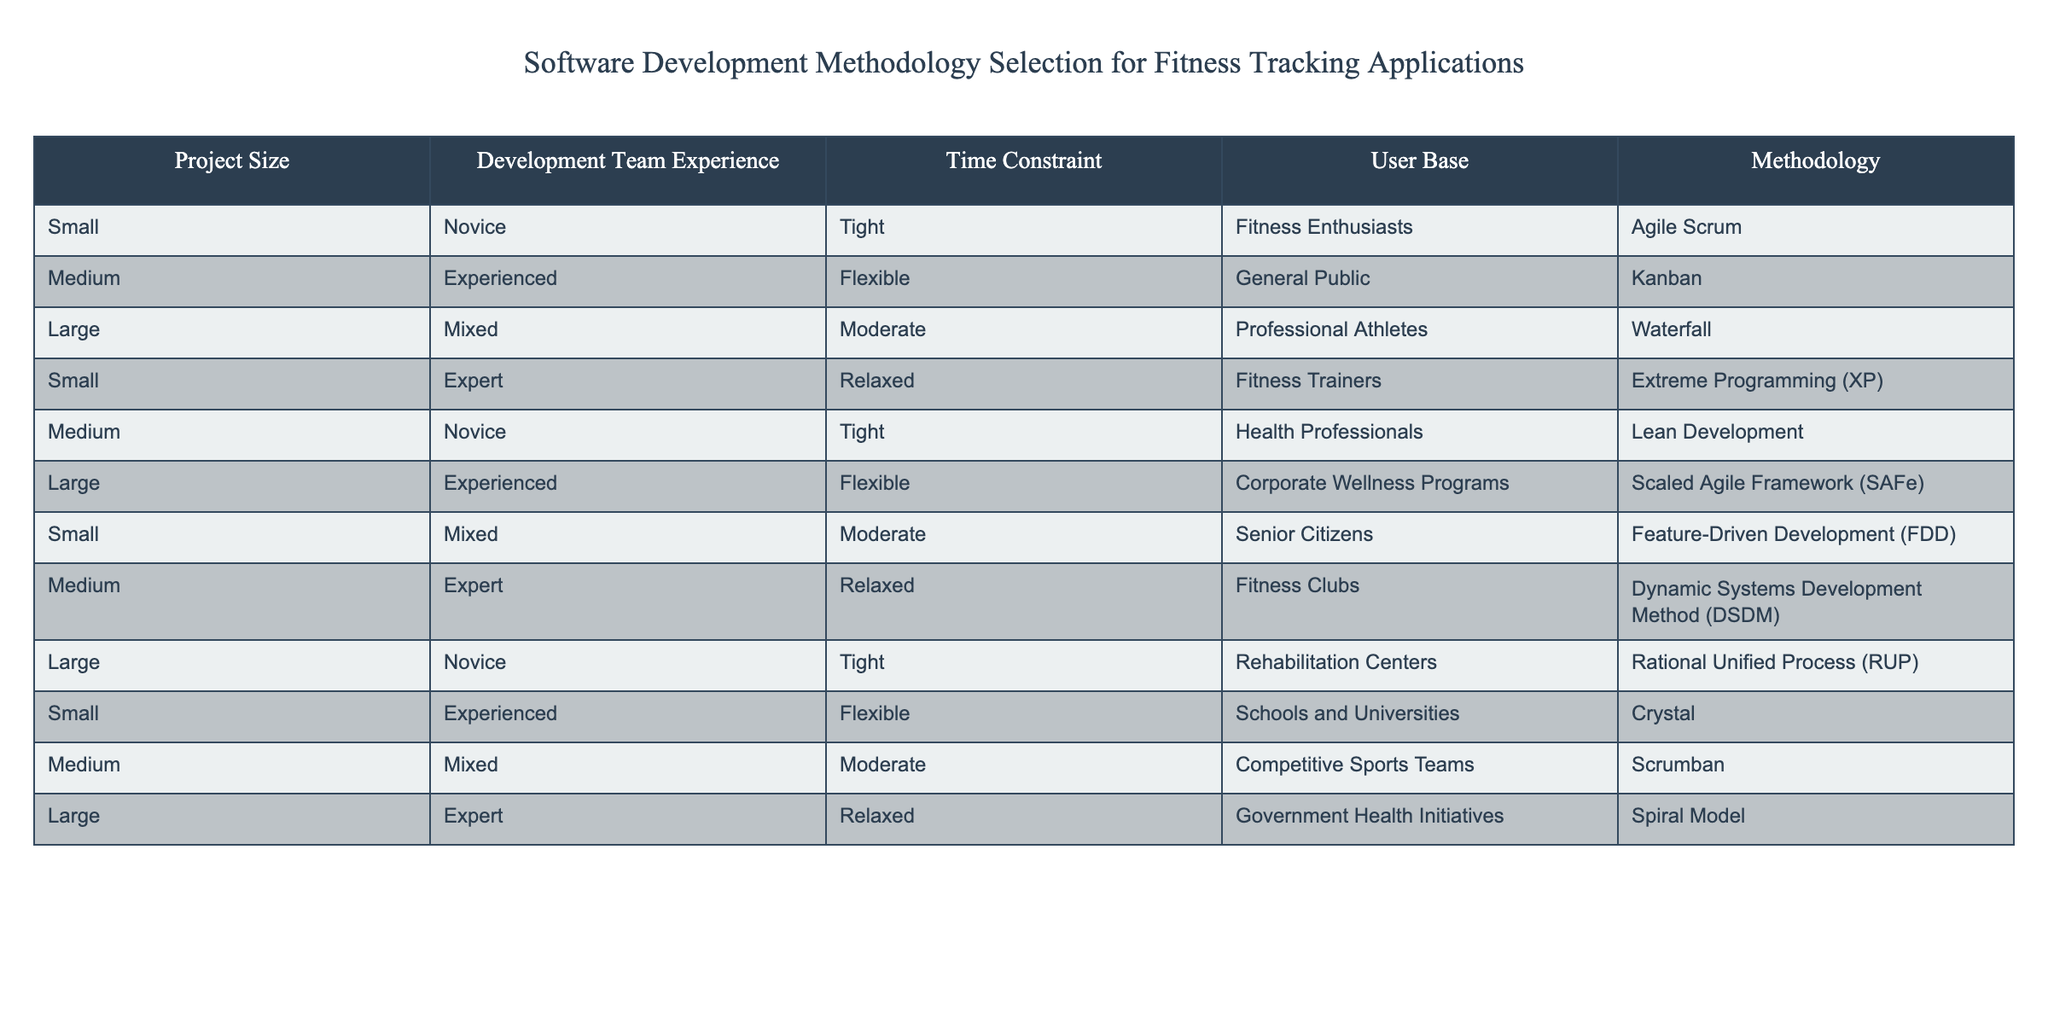What methodology is recommended for small projects with novice teams facing tight deadlines? The table indicates that for small projects with novice teams and tight time constraints, the recommended methodology is Agile Scrum.
Answer: Agile Scrum Which methodology is associated with medium-sized projects and experienced teams working with the general public? According to the table, medium-sized projects with experienced teams focusing on the general public should use Kanban.
Answer: Kanban Are there any large projects that utilize the Waterfall methodology? Yes, the table shows that large projects aimed at professional athletes use the Waterfall methodology.
Answer: Yes What is the methodology for small projects with expert teams that have relaxed time constraints? The data indicates that small projects with expert teams and relaxed deadlines should use Extreme Programming (XP).
Answer: Extreme Programming (XP) What is the total number of methodologies listed for large projects? The table lists three methodologies for large projects: Waterfall, Scaled Agile Framework (SAFe), and Spiral Model. Therefore, the total is 3 methodologies.
Answer: 3 Which methodology is selected for medium-sized projects with novice teams and tight deadlines, and what type of user base does it target? The table specifies that medium-sized projects with novice teams under tight deadlines employ Lean Development and target health professionals as the user base.
Answer: Lean Development, Health Professionals Is there a methodology that combines the features of both Agile and Waterfall? Based on the table, there is no direct indication of a methodology combining features of Agile and Waterfall; rather, methodologies like Scrumban or Scaled Agile Framework (SAFe) incorporate elements from different methodologies but do not explicitly merge Agile and Waterfall.
Answer: No What percentage of the methodologies target a flexible time constraint category? There are 6 methodologies in total listed in the table: Agile Scrum, Kanban, Waterfall, Extreme Programming (XP), Scaled Agile Framework (SAFe), and Dynamic Systems Development Method (DSDM) of which 4 target flexible time constraints (Kanban, Scaled Agile Framework (SAFe), Crystal, and Spiral Model). This results in a percentage of (4/12)*100 = 33.33%.
Answer: 33.33% For large projects aimed at rehabilitation centers, which methodology is utilized? The table illustrates that large projects targeted at rehabilitation centers employ the Rational Unified Process (RUP).
Answer: Rational Unified Process (RUP) 